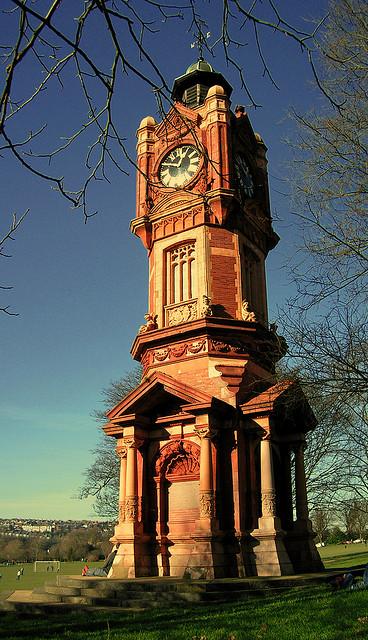What is the purpose of this building?
Concise answer only. Clock. Is this a tower?
Give a very brief answer. Yes. How many clock faces does this building have?
Keep it brief. 2. 